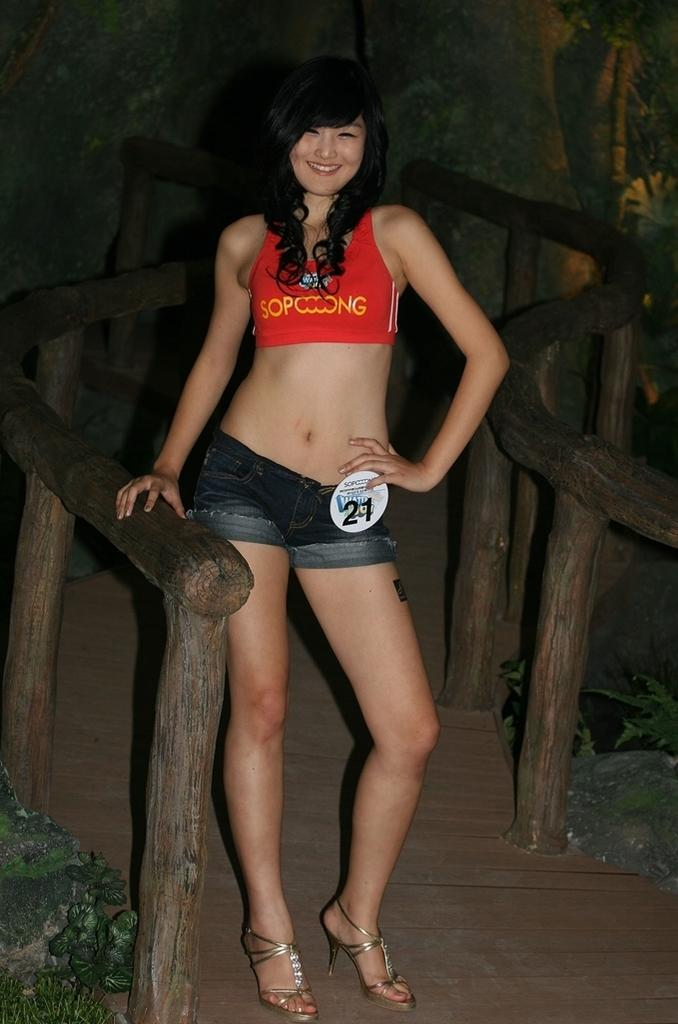Who is present in the image? There is a woman in the image. What is the woman doing in the image? The woman is standing and smiling. What can be seen at the bottom left corner of the image? There are plants at the left bottom of the image. What material is present on the left side of the image? There is wood on the left side of the image. How would you describe the background of the image? The background of the image is dark. What type of glass is used in the image? There is no glass present in the image. What flavor of plane is depicted in the image? There is no plane present in the image. 